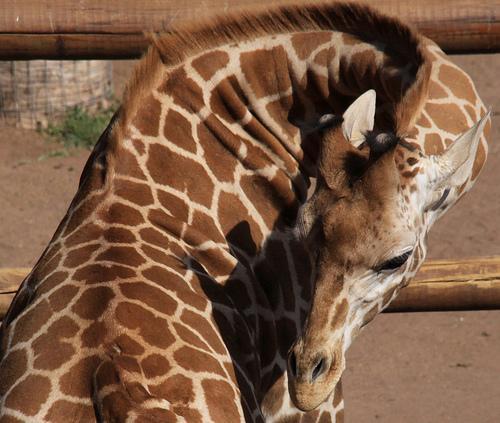How many giraffes are pictured?
Give a very brief answer. 1. 